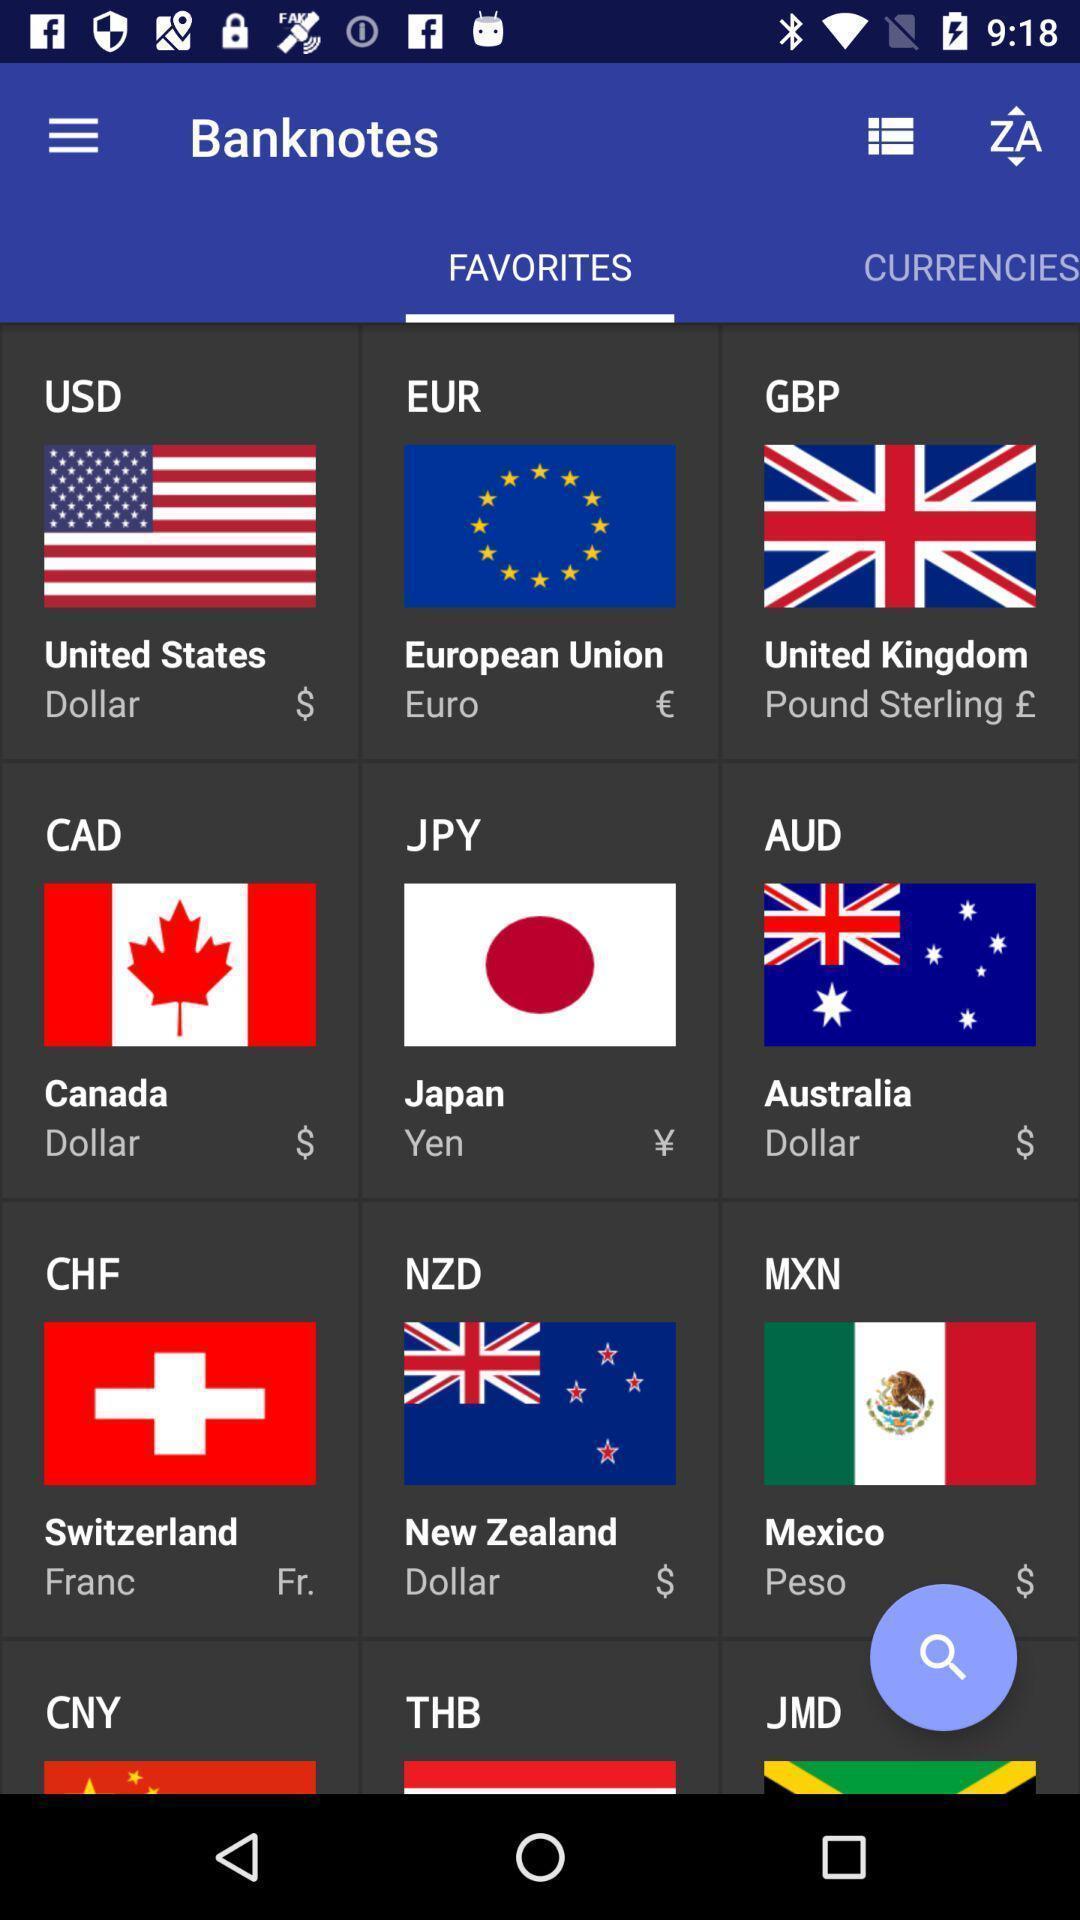Provide a detailed account of this screenshot. Page with list of different currencies. 